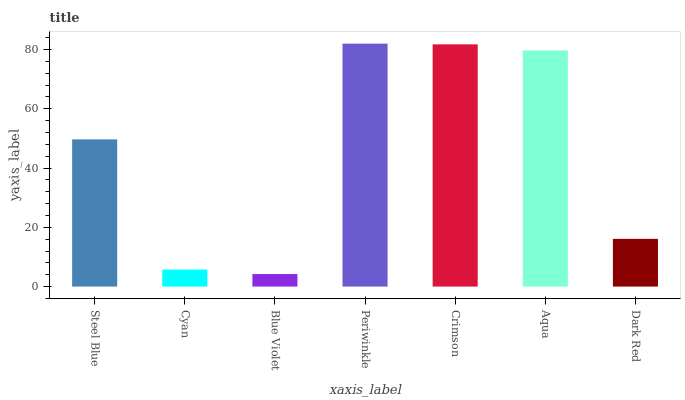Is Blue Violet the minimum?
Answer yes or no. Yes. Is Periwinkle the maximum?
Answer yes or no. Yes. Is Cyan the minimum?
Answer yes or no. No. Is Cyan the maximum?
Answer yes or no. No. Is Steel Blue greater than Cyan?
Answer yes or no. Yes. Is Cyan less than Steel Blue?
Answer yes or no. Yes. Is Cyan greater than Steel Blue?
Answer yes or no. No. Is Steel Blue less than Cyan?
Answer yes or no. No. Is Steel Blue the high median?
Answer yes or no. Yes. Is Steel Blue the low median?
Answer yes or no. Yes. Is Aqua the high median?
Answer yes or no. No. Is Periwinkle the low median?
Answer yes or no. No. 